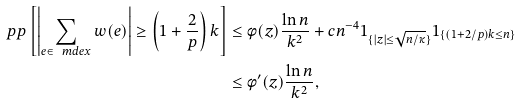<formula> <loc_0><loc_0><loc_500><loc_500>\ p p \left [ \left | \sum _ { e \in \ m d e x } w ( e ) \right | \geq \left ( 1 + \frac { 2 } { p } \right ) k \right ] & \leq \phi ( z ) \frac { \ln n } { k ^ { 2 } } + c n ^ { - 4 } 1 _ { \{ | z | \leq \sqrt { n / \kappa } \} } 1 _ { \{ ( 1 + 2 / p ) k \leq n \} } \\ & \leq \phi ^ { \prime } ( z ) \frac { \ln n } { k ^ { 2 } } ,</formula> 